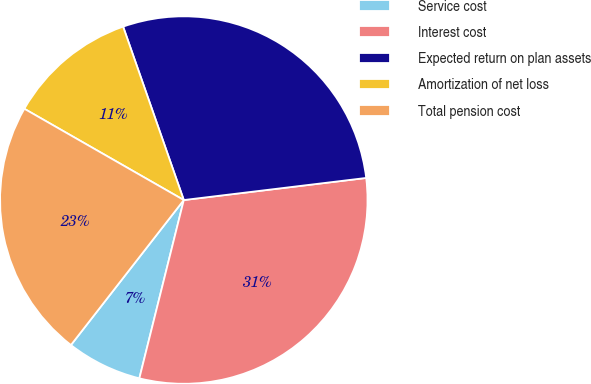Convert chart. <chart><loc_0><loc_0><loc_500><loc_500><pie_chart><fcel>Service cost<fcel>Interest cost<fcel>Expected return on plan assets<fcel>Amortization of net loss<fcel>Total pension cost<nl><fcel>6.64%<fcel>30.81%<fcel>28.44%<fcel>11.37%<fcel>22.75%<nl></chart> 